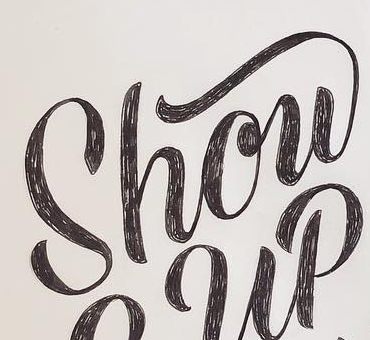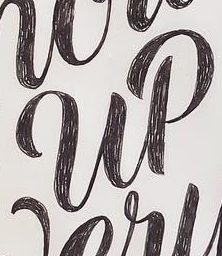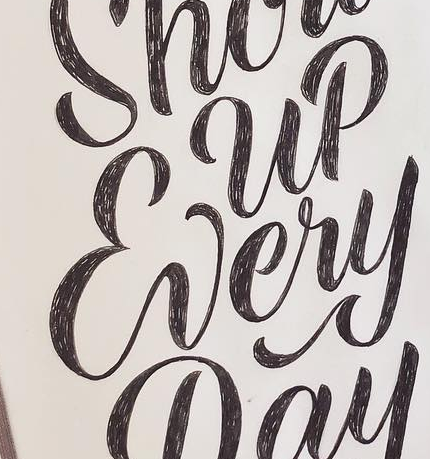Read the text from these images in sequence, separated by a semicolon. Show; up; Every 